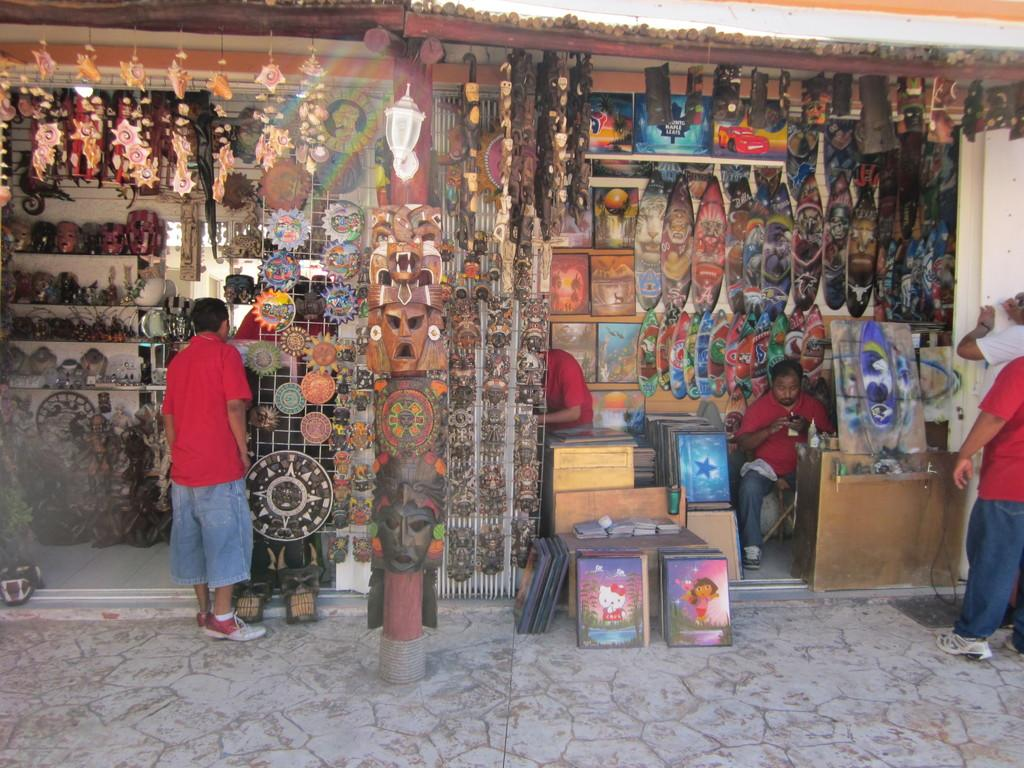What are the people in the image wearing? The people in the image are wearing red tee shirts. What can be seen hanging on the shelves in the image? There are frames and sculptures hanging and arranged on the shelves in the image. What type of objects are displayed in the frames? The facts provided do not specify the content of the frames, so we cannot determine what is displayed in them. What type of oatmeal is being served to the laborers in the image? There is no mention of oatmeal or laborers in the image, so we cannot answer this question. 